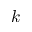<formula> <loc_0><loc_0><loc_500><loc_500>k</formula> 